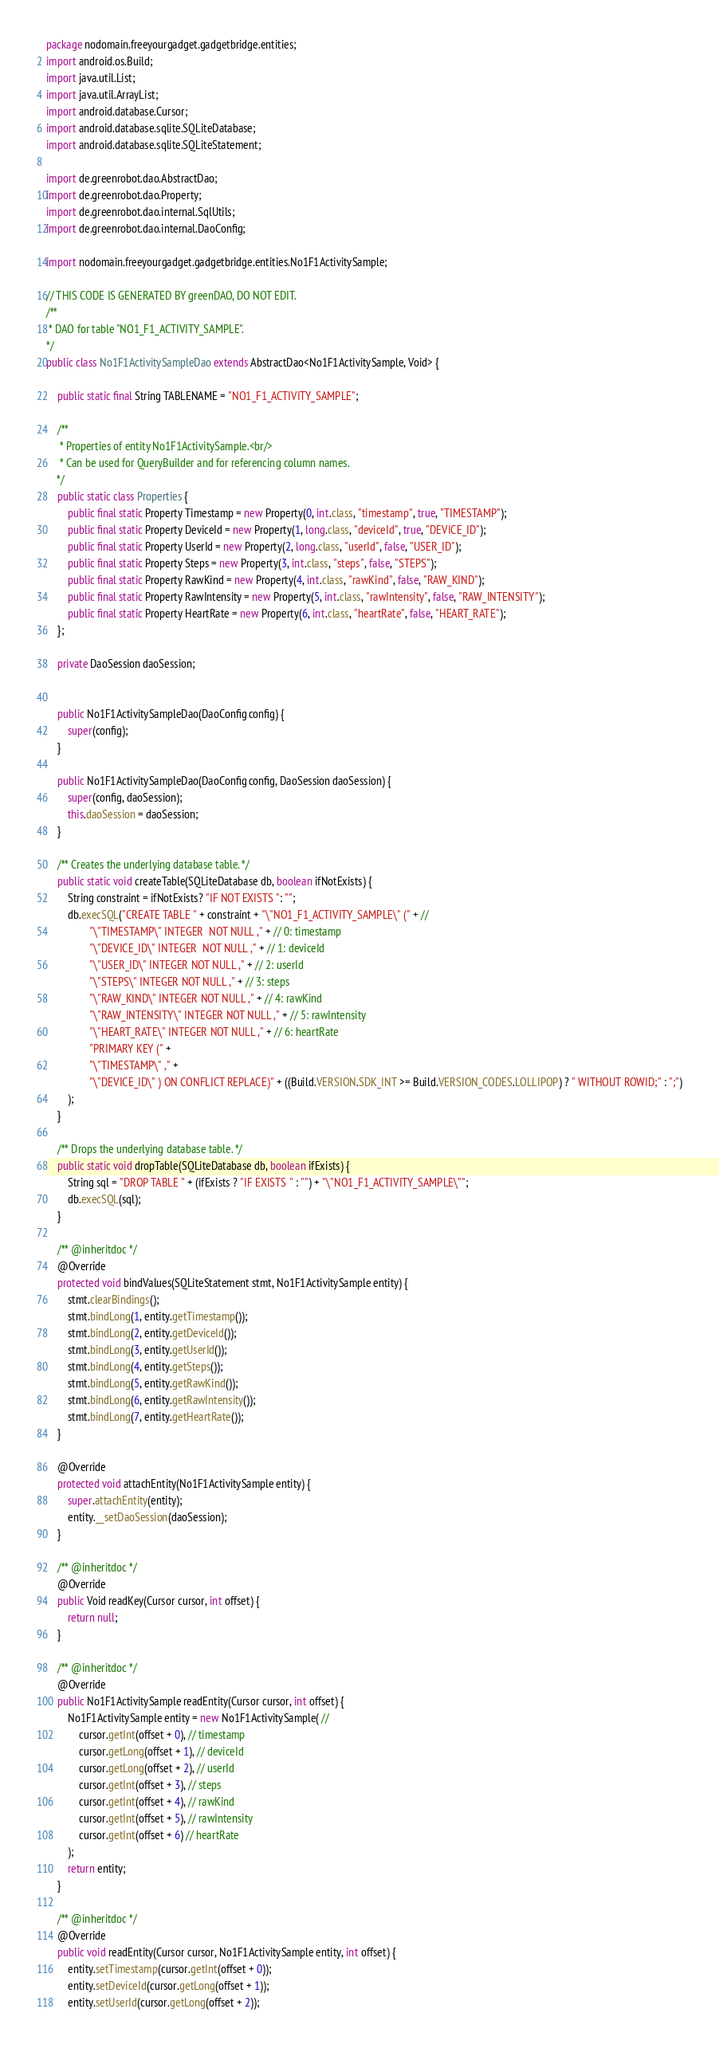Convert code to text. <code><loc_0><loc_0><loc_500><loc_500><_Java_>package nodomain.freeyourgadget.gadgetbridge.entities;
import android.os.Build;
import java.util.List;
import java.util.ArrayList;
import android.database.Cursor;
import android.database.sqlite.SQLiteDatabase;
import android.database.sqlite.SQLiteStatement;

import de.greenrobot.dao.AbstractDao;
import de.greenrobot.dao.Property;
import de.greenrobot.dao.internal.SqlUtils;
import de.greenrobot.dao.internal.DaoConfig;

import nodomain.freeyourgadget.gadgetbridge.entities.No1F1ActivitySample;

// THIS CODE IS GENERATED BY greenDAO, DO NOT EDIT.
/** 
 * DAO for table "NO1_F1_ACTIVITY_SAMPLE".
*/
public class No1F1ActivitySampleDao extends AbstractDao<No1F1ActivitySample, Void> {

    public static final String TABLENAME = "NO1_F1_ACTIVITY_SAMPLE";

    /**
     * Properties of entity No1F1ActivitySample.<br/>
     * Can be used for QueryBuilder and for referencing column names.
    */
    public static class Properties {
        public final static Property Timestamp = new Property(0, int.class, "timestamp", true, "TIMESTAMP");
        public final static Property DeviceId = new Property(1, long.class, "deviceId", true, "DEVICE_ID");
        public final static Property UserId = new Property(2, long.class, "userId", false, "USER_ID");
        public final static Property Steps = new Property(3, int.class, "steps", false, "STEPS");
        public final static Property RawKind = new Property(4, int.class, "rawKind", false, "RAW_KIND");
        public final static Property RawIntensity = new Property(5, int.class, "rawIntensity", false, "RAW_INTENSITY");
        public final static Property HeartRate = new Property(6, int.class, "heartRate", false, "HEART_RATE");
    };

    private DaoSession daoSession;


    public No1F1ActivitySampleDao(DaoConfig config) {
        super(config);
    }
    
    public No1F1ActivitySampleDao(DaoConfig config, DaoSession daoSession) {
        super(config, daoSession);
        this.daoSession = daoSession;
    }

    /** Creates the underlying database table. */
    public static void createTable(SQLiteDatabase db, boolean ifNotExists) {
        String constraint = ifNotExists? "IF NOT EXISTS ": "";
        db.execSQL("CREATE TABLE " + constraint + "\"NO1_F1_ACTIVITY_SAMPLE\" (" + //
                "\"TIMESTAMP\" INTEGER  NOT NULL ," + // 0: timestamp
                "\"DEVICE_ID\" INTEGER  NOT NULL ," + // 1: deviceId
                "\"USER_ID\" INTEGER NOT NULL ," + // 2: userId
                "\"STEPS\" INTEGER NOT NULL ," + // 3: steps
                "\"RAW_KIND\" INTEGER NOT NULL ," + // 4: rawKind
                "\"RAW_INTENSITY\" INTEGER NOT NULL ," + // 5: rawIntensity
                "\"HEART_RATE\" INTEGER NOT NULL ," + // 6: heartRate
                "PRIMARY KEY (" +
                "\"TIMESTAMP\" ," +
                "\"DEVICE_ID\" ) ON CONFLICT REPLACE)" + ((Build.VERSION.SDK_INT >= Build.VERSION_CODES.LOLLIPOP) ? " WITHOUT ROWID;" : ";")
        );
    }

    /** Drops the underlying database table. */
    public static void dropTable(SQLiteDatabase db, boolean ifExists) {
        String sql = "DROP TABLE " + (ifExists ? "IF EXISTS " : "") + "\"NO1_F1_ACTIVITY_SAMPLE\"";
        db.execSQL(sql);
    }

    /** @inheritdoc */
    @Override
    protected void bindValues(SQLiteStatement stmt, No1F1ActivitySample entity) {
        stmt.clearBindings();
        stmt.bindLong(1, entity.getTimestamp());
        stmt.bindLong(2, entity.getDeviceId());
        stmt.bindLong(3, entity.getUserId());
        stmt.bindLong(4, entity.getSteps());
        stmt.bindLong(5, entity.getRawKind());
        stmt.bindLong(6, entity.getRawIntensity());
        stmt.bindLong(7, entity.getHeartRate());
    }

    @Override
    protected void attachEntity(No1F1ActivitySample entity) {
        super.attachEntity(entity);
        entity.__setDaoSession(daoSession);
    }

    /** @inheritdoc */
    @Override
    public Void readKey(Cursor cursor, int offset) {
        return null;
    }    

    /** @inheritdoc */
    @Override
    public No1F1ActivitySample readEntity(Cursor cursor, int offset) {
        No1F1ActivitySample entity = new No1F1ActivitySample( //
            cursor.getInt(offset + 0), // timestamp
            cursor.getLong(offset + 1), // deviceId
            cursor.getLong(offset + 2), // userId
            cursor.getInt(offset + 3), // steps
            cursor.getInt(offset + 4), // rawKind
            cursor.getInt(offset + 5), // rawIntensity
            cursor.getInt(offset + 6) // heartRate
        );
        return entity;
    }
     
    /** @inheritdoc */
    @Override
    public void readEntity(Cursor cursor, No1F1ActivitySample entity, int offset) {
        entity.setTimestamp(cursor.getInt(offset + 0));
        entity.setDeviceId(cursor.getLong(offset + 1));
        entity.setUserId(cursor.getLong(offset + 2));</code> 